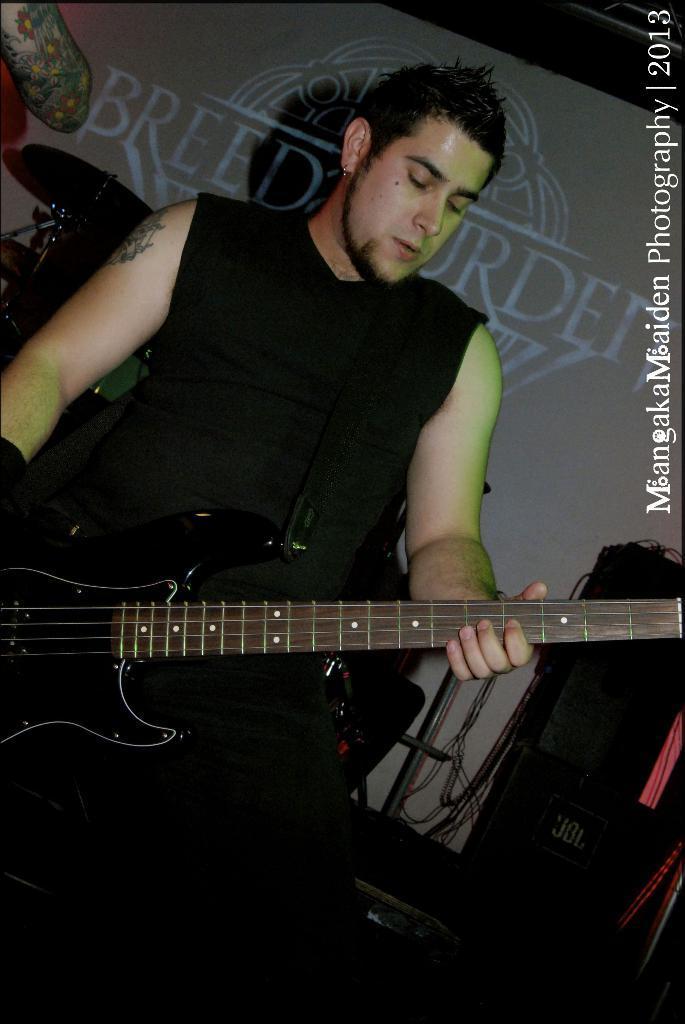In one or two sentences, can you explain what this image depicts? In this image I see a man who is holding a guitar in his hands and I see the watermark over here. In the background I see something is written over here and I see few things over here and I see the wires and it is dark over here. 